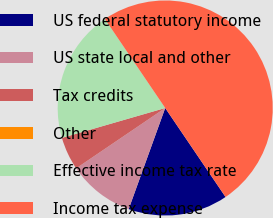<chart> <loc_0><loc_0><loc_500><loc_500><pie_chart><fcel>US federal statutory income<fcel>US state local and other<fcel>Tax credits<fcel>Other<fcel>Effective income tax rate<fcel>Income tax expense<nl><fcel>15.0%<fcel>10.0%<fcel>5.0%<fcel>0.0%<fcel>20.0%<fcel>49.99%<nl></chart> 